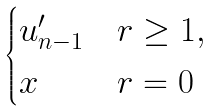Convert formula to latex. <formula><loc_0><loc_0><loc_500><loc_500>\begin{cases} u _ { n - 1 } ^ { \prime } & r \geq 1 , \\ x & r = 0 \end{cases}</formula> 